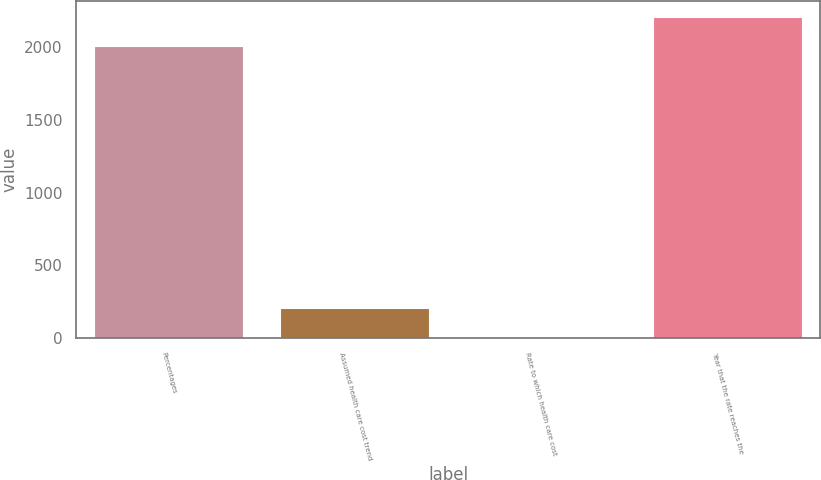Convert chart. <chart><loc_0><loc_0><loc_500><loc_500><bar_chart><fcel>Percentages<fcel>Assumed health care cost trend<fcel>Rate to which health care cost<fcel>Year that the rate reaches the<nl><fcel>2005<fcel>205.5<fcel>5<fcel>2205.5<nl></chart> 